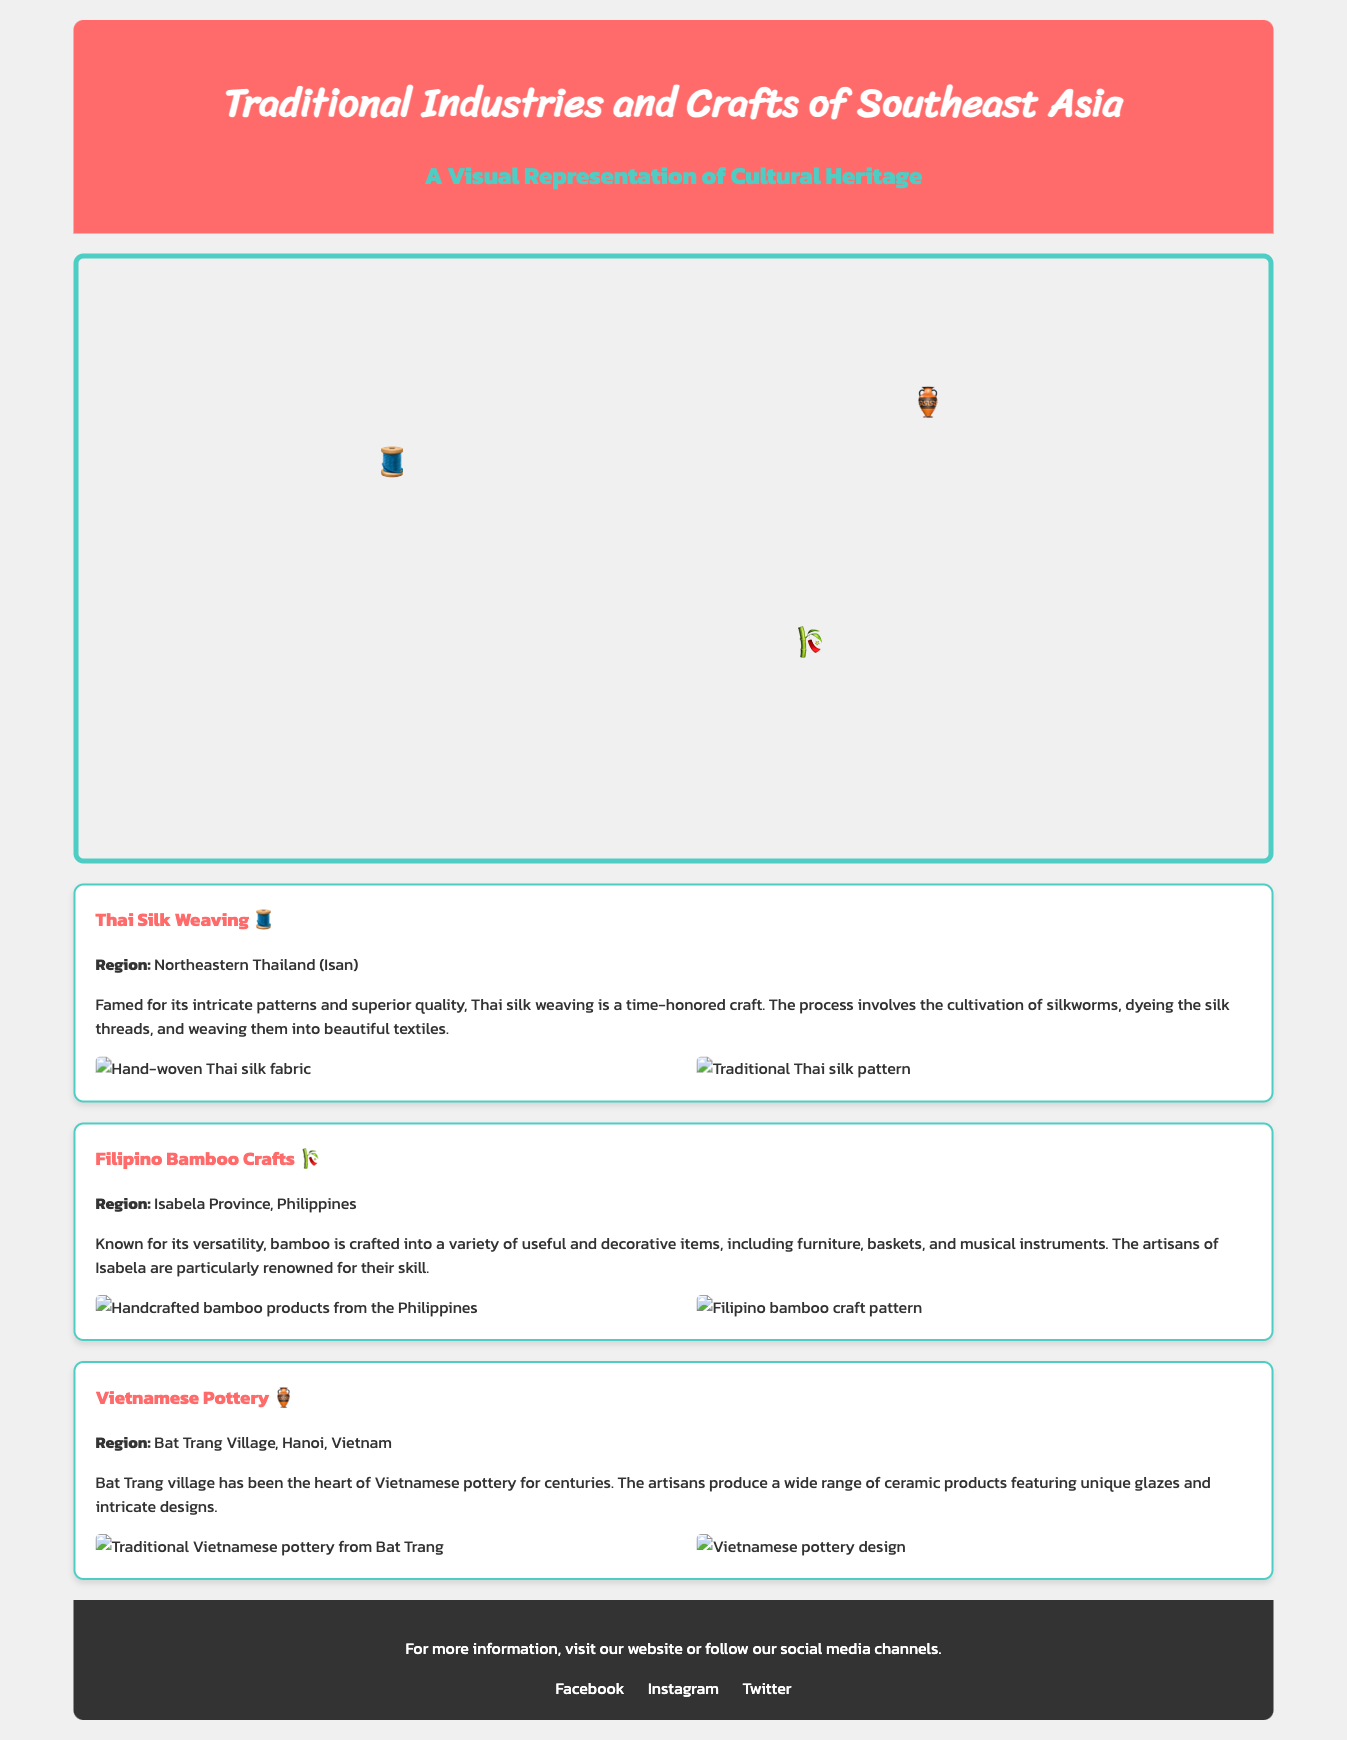What is the craft symbol for Thai silk weaving? The craft symbol for Thai silk weaving is represented by the emoji 🧵.
Answer: 🧵 Which region is known for Filipino bamboo crafts? The document states that Filipino bamboo crafts are associated with Isabela Province, Philippines.
Answer: Isabela Province What kind of pottery is produced in Bat Trang Village? The document indicates that the pottery produced in Bat Trang Village features unique glazes and intricate designs.
Answer: Vietnamese pottery How many crafts are featured in the document? The document lists three crafts: Thai silk weaving, Filipino bamboo crafts, and Vietnamese pottery.
Answer: Three What fabric is known for its intricate patterns in Thailand? The document specifically mentions that Thai silk weaving is renowned for its intricate patterns and superior quality.
Answer: Thai silk What region does Thai silk weaving originate from? The document identifies the region known for Thai silk weaving as Northeastern Thailand (Isan).
Answer: Northeastern Thailand (Isan) Which craft is associated with the emoji 🎋? The emoji 🎋 represents Filipino bamboo crafts, as indicated in the document.
Answer: Filipino Bamboo Crafts What type of products are made from bamboo in the Philippines? The document describes that bamboo is crafted into furniture, baskets, and musical instruments.
Answer: Furniture, baskets, and musical instruments 